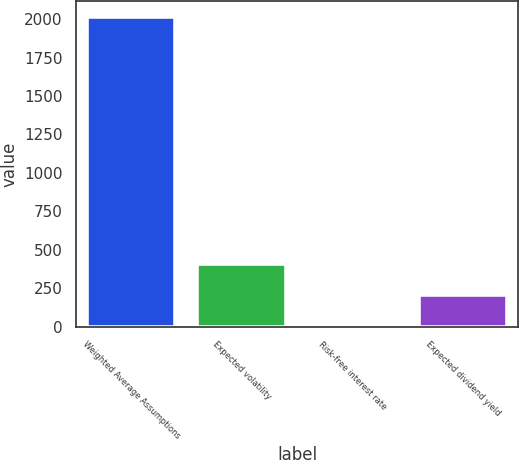Convert chart to OTSL. <chart><loc_0><loc_0><loc_500><loc_500><bar_chart><fcel>Weighted Average Assumptions<fcel>Expected volatility<fcel>Risk-free interest rate<fcel>Expected dividend yield<nl><fcel>2015<fcel>404.36<fcel>1.7<fcel>203.03<nl></chart> 